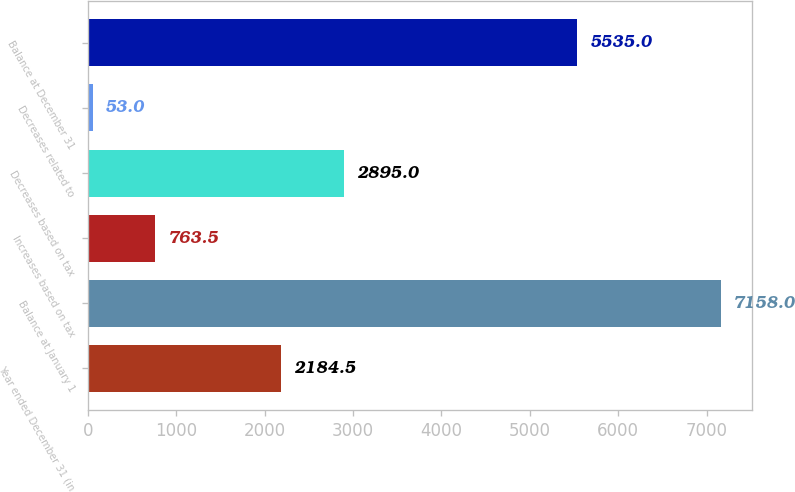Convert chart. <chart><loc_0><loc_0><loc_500><loc_500><bar_chart><fcel>Year ended December 31 (in<fcel>Balance at January 1<fcel>Increases based on tax<fcel>Decreases based on tax<fcel>Decreases related to<fcel>Balance at December 31<nl><fcel>2184.5<fcel>7158<fcel>763.5<fcel>2895<fcel>53<fcel>5535<nl></chart> 